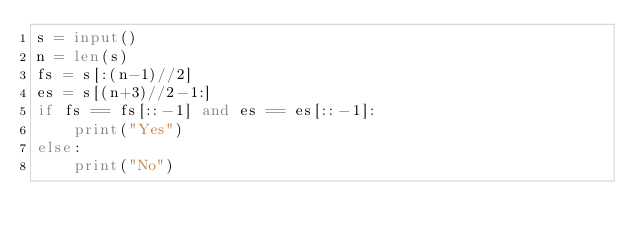Convert code to text. <code><loc_0><loc_0><loc_500><loc_500><_Python_>s = input()
n = len(s)
fs = s[:(n-1)//2]
es = s[(n+3)//2-1:]
if fs == fs[::-1] and es == es[::-1]:
    print("Yes")
else:
    print("No")</code> 